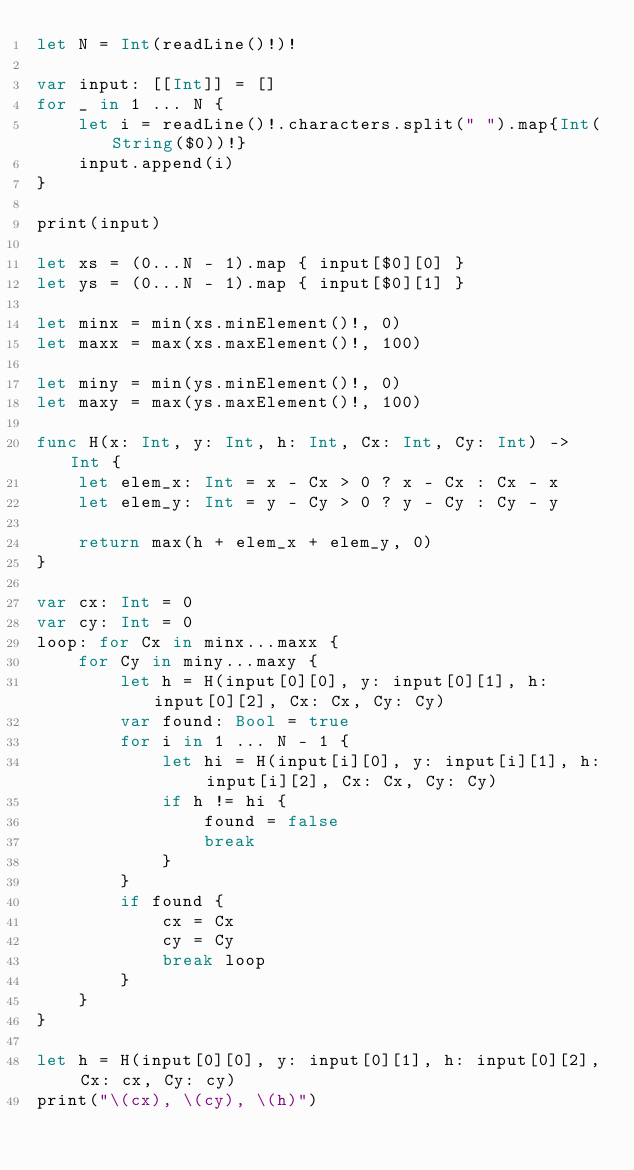Convert code to text. <code><loc_0><loc_0><loc_500><loc_500><_Swift_>let N = Int(readLine()!)!

var input: [[Int]] = []
for _ in 1 ... N {
    let i = readLine()!.characters.split(" ").map{Int(String($0))!}
    input.append(i)
}

print(input)

let xs = (0...N - 1).map { input[$0][0] }
let ys = (0...N - 1).map { input[$0][1] }

let minx = min(xs.minElement()!, 0)
let maxx = max(xs.maxElement()!, 100)

let miny = min(ys.minElement()!, 0)
let maxy = max(ys.maxElement()!, 100)

func H(x: Int, y: Int, h: Int, Cx: Int, Cy: Int) -> Int {
    let elem_x: Int = x - Cx > 0 ? x - Cx : Cx - x
    let elem_y: Int = y - Cy > 0 ? y - Cy : Cy - y
    
    return max(h + elem_x + elem_y, 0)
}

var cx: Int = 0
var cy: Int = 0
loop: for Cx in minx...maxx {
    for Cy in miny...maxy {
        let h = H(input[0][0], y: input[0][1], h: input[0][2], Cx: Cx, Cy: Cy)
        var found: Bool = true
        for i in 1 ... N - 1 {
            let hi = H(input[i][0], y: input[i][1], h: input[i][2], Cx: Cx, Cy: Cy)
            if h != hi {
                found = false
                break
            }
        }
        if found {
            cx = Cx
            cy = Cy
            break loop
        }
    }
}

let h = H(input[0][0], y: input[0][1], h: input[0][2], Cx: cx, Cy: cy)
print("\(cx), \(cy), \(h)")
</code> 